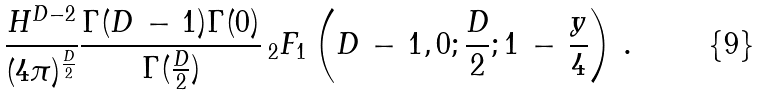<formula> <loc_0><loc_0><loc_500><loc_500>\frac { H ^ { D - 2 } } { ( 4 \pi ) ^ { \frac { D } 2 } } \frac { \Gamma ( D \, - \, 1 ) \Gamma ( 0 ) } { \Gamma ( \frac { D } 2 ) } \, _ { 2 } F _ { 1 } \left ( D \, - \, 1 , 0 ; \frac { D } 2 ; 1 \, - \, \frac { y } 4 \right ) \, .</formula> 